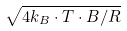<formula> <loc_0><loc_0><loc_500><loc_500>\sqrt { 4 k _ { B } \cdot T \cdot B / R }</formula> 